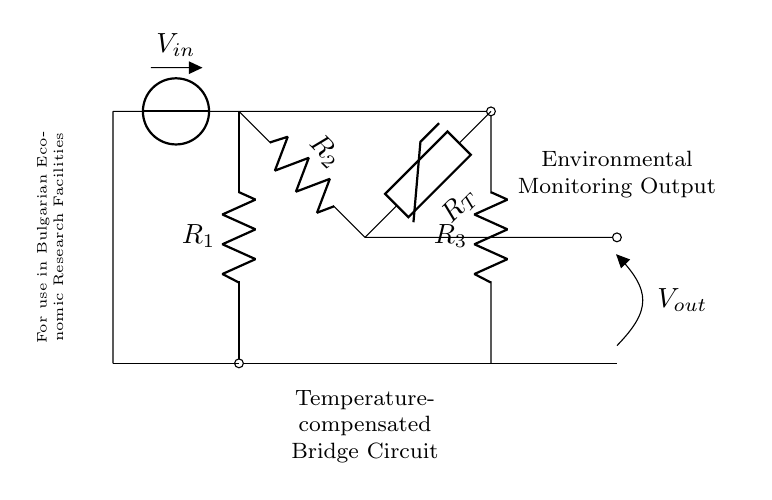What type of circuit is this? The circuit shown is a bridge circuit, characterized by its configuration of resistors and one thermistor arranged in a way to measure resistance changes.
Answer: bridge circuit What is the purpose of the thermistor in this circuit? The thermistor, labeled R_T, changes its resistance in response to temperature variations, which is the key function for environmental monitoring.
Answer: environmental monitoring How many resistors are present in the circuit? Counting the components, there are three resistors in the circuit: R_1, R_2, and R_3.
Answer: three resistors What is the input voltage labeled in the circuit? The voltage source labeled V_in specifies the input voltage supplied to the circuit. The diagram does not provide a numerical value, but it is the voltage that powers the bridge.
Answer: V_in What does the output voltage indicate? The output voltage, denoted as V_out, represents the difference in voltage across the bridge circuit, which correlates to the temperature readings from the thermistor.
Answer: V_out How does temperature affect the circuit's output? As the temperature changes, the resistance of the thermistor alters, which in turn modifies the balance of the bridge and results in a change in the output voltage V_out, reflecting the temperature change.
Answer: it changes V_out What is the significance of temperature compensation in this bridge? Temperature compensation is critical for accurate measurements, as it helps stabilize the output of the bridge against temperature variations that could affect the readings from other resistors.
Answer: stabilizes output 